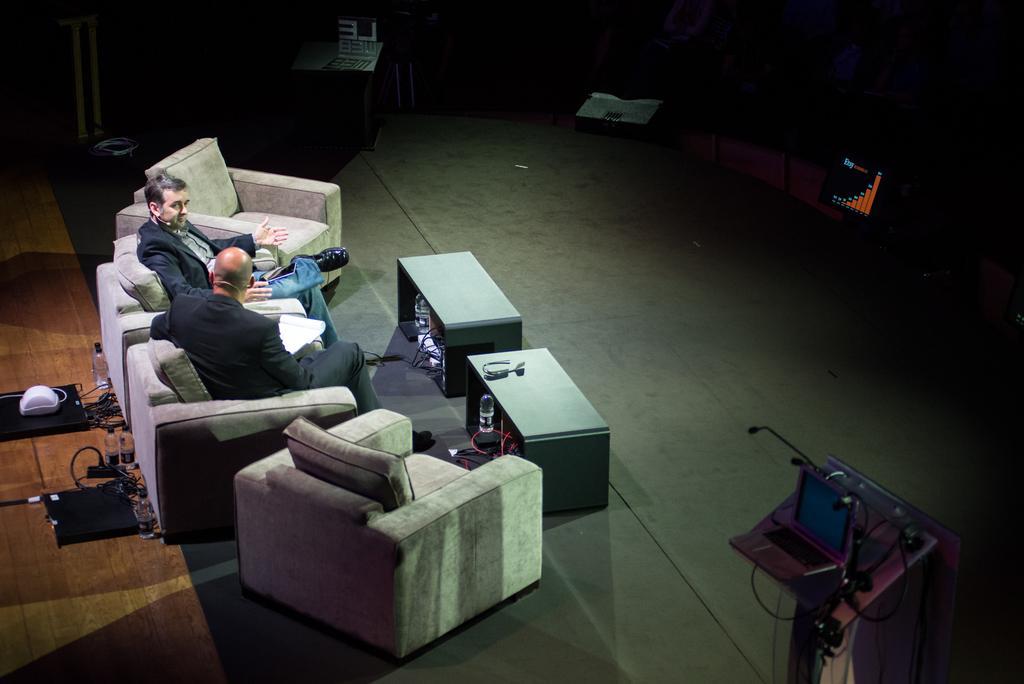How would you summarize this image in a sentence or two? In image there are two person siting on the couch. There is a podium and a laptop and a water bottle on the floor. 